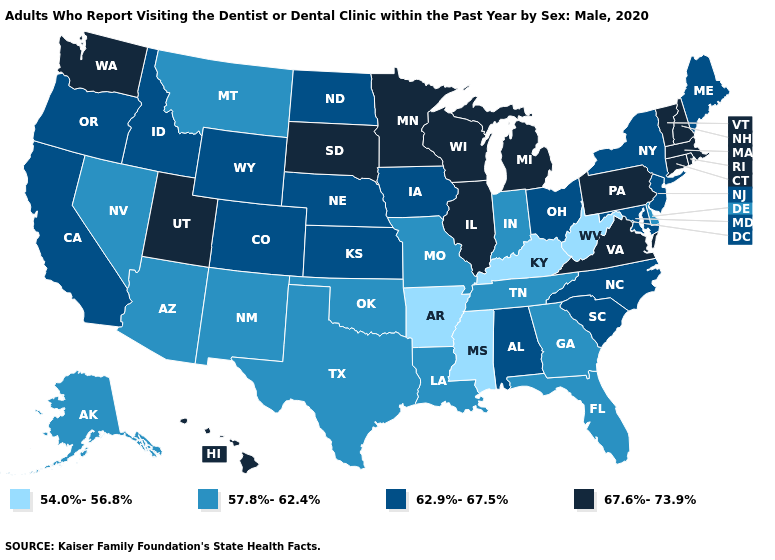What is the value of Nebraska?
Answer briefly. 62.9%-67.5%. Among the states that border South Carolina , which have the highest value?
Write a very short answer. North Carolina. Does New York have a lower value than Massachusetts?
Be succinct. Yes. Does Montana have the highest value in the West?
Be succinct. No. What is the lowest value in states that border Connecticut?
Quick response, please. 62.9%-67.5%. Name the states that have a value in the range 62.9%-67.5%?
Give a very brief answer. Alabama, California, Colorado, Idaho, Iowa, Kansas, Maine, Maryland, Nebraska, New Jersey, New York, North Carolina, North Dakota, Ohio, Oregon, South Carolina, Wyoming. What is the highest value in the USA?
Write a very short answer. 67.6%-73.9%. Does Texas have the highest value in the USA?
Write a very short answer. No. Does the map have missing data?
Keep it brief. No. What is the value of Georgia?
Quick response, please. 57.8%-62.4%. Does Connecticut have the highest value in the Northeast?
Answer briefly. Yes. Name the states that have a value in the range 54.0%-56.8%?
Quick response, please. Arkansas, Kentucky, Mississippi, West Virginia. Name the states that have a value in the range 62.9%-67.5%?
Keep it brief. Alabama, California, Colorado, Idaho, Iowa, Kansas, Maine, Maryland, Nebraska, New Jersey, New York, North Carolina, North Dakota, Ohio, Oregon, South Carolina, Wyoming. Name the states that have a value in the range 57.8%-62.4%?
Answer briefly. Alaska, Arizona, Delaware, Florida, Georgia, Indiana, Louisiana, Missouri, Montana, Nevada, New Mexico, Oklahoma, Tennessee, Texas. Name the states that have a value in the range 67.6%-73.9%?
Write a very short answer. Connecticut, Hawaii, Illinois, Massachusetts, Michigan, Minnesota, New Hampshire, Pennsylvania, Rhode Island, South Dakota, Utah, Vermont, Virginia, Washington, Wisconsin. 